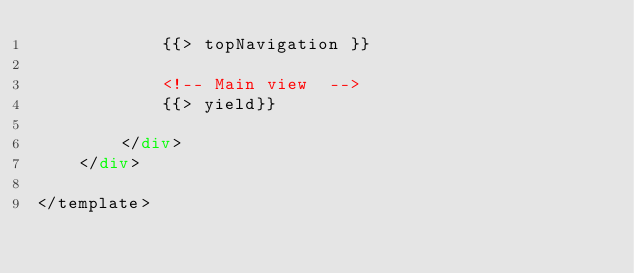Convert code to text. <code><loc_0><loc_0><loc_500><loc_500><_HTML_>            {{> topNavigation }}

            <!-- Main view  -->
            {{> yield}}

        </div>
    </div>

</template>
</code> 